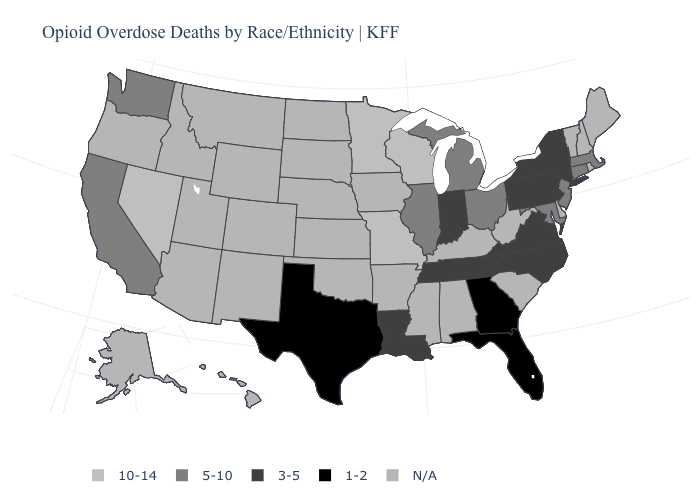What is the value of Nebraska?
Be succinct. N/A. How many symbols are there in the legend?
Keep it brief. 5. What is the value of Minnesota?
Give a very brief answer. 10-14. What is the lowest value in the USA?
Short answer required. 1-2. Does Wisconsin have the highest value in the MidWest?
Quick response, please. Yes. Name the states that have a value in the range 1-2?
Give a very brief answer. Florida, Georgia, Texas. What is the lowest value in the MidWest?
Be succinct. 3-5. What is the highest value in states that border Texas?
Write a very short answer. 3-5. Does Missouri have the highest value in the USA?
Keep it brief. Yes. Name the states that have a value in the range 10-14?
Answer briefly. Minnesota, Missouri, Nevada, Wisconsin. Which states have the lowest value in the West?
Keep it brief. California, Washington. Name the states that have a value in the range 1-2?
Give a very brief answer. Florida, Georgia, Texas. Name the states that have a value in the range 10-14?
Keep it brief. Minnesota, Missouri, Nevada, Wisconsin. What is the value of Georgia?
Quick response, please. 1-2. Does Georgia have the lowest value in the USA?
Quick response, please. Yes. 